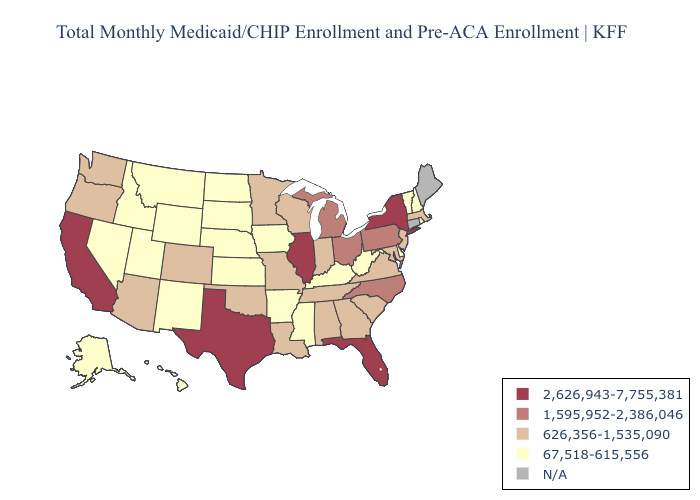What is the value of Nebraska?
Answer briefly. 67,518-615,556. Name the states that have a value in the range 2,626,943-7,755,381?
Give a very brief answer. California, Florida, Illinois, New York, Texas. What is the highest value in the USA?
Quick response, please. 2,626,943-7,755,381. Does the map have missing data?
Short answer required. Yes. What is the value of Ohio?
Short answer required. 1,595,952-2,386,046. Name the states that have a value in the range 626,356-1,535,090?
Answer briefly. Alabama, Arizona, Colorado, Georgia, Indiana, Louisiana, Maryland, Massachusetts, Minnesota, Missouri, New Jersey, Oklahoma, Oregon, South Carolina, Tennessee, Virginia, Washington, Wisconsin. Among the states that border Vermont , does New Hampshire have the lowest value?
Write a very short answer. Yes. Name the states that have a value in the range 626,356-1,535,090?
Short answer required. Alabama, Arizona, Colorado, Georgia, Indiana, Louisiana, Maryland, Massachusetts, Minnesota, Missouri, New Jersey, Oklahoma, Oregon, South Carolina, Tennessee, Virginia, Washington, Wisconsin. Name the states that have a value in the range 2,626,943-7,755,381?
Be succinct. California, Florida, Illinois, New York, Texas. Among the states that border Oklahoma , does New Mexico have the highest value?
Be succinct. No. What is the value of Tennessee?
Short answer required. 626,356-1,535,090. 